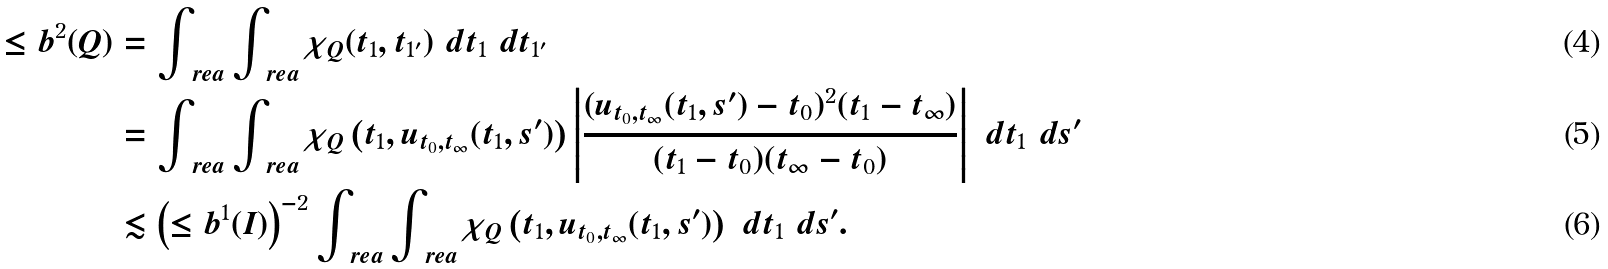Convert formula to latex. <formula><loc_0><loc_0><loc_500><loc_500>\leq b ^ { 2 } ( Q ) & = \int _ { \ r e a } \int _ { \ r e a } \chi _ { Q } ( t _ { 1 } , t _ { 1 ^ { \prime } } ) \ d t _ { 1 } \ d t _ { 1 ^ { \prime } } \\ & = \int _ { \ r e a } \int _ { \ r e a } \chi _ { Q } \left ( t _ { 1 } , u _ { t _ { 0 } , t _ { \infty } } ( t _ { 1 } , s ^ { \prime } ) \right ) \left | \frac { ( u _ { t _ { 0 } , t _ { \infty } } ( t _ { 1 } , s ^ { \prime } ) - t _ { 0 } ) ^ { 2 } ( t _ { 1 } - t _ { \infty } ) } { ( t _ { 1 } - t _ { 0 } ) ( t _ { \infty } - t _ { 0 } ) } \right | \ d t _ { 1 } \ d s ^ { \prime } \\ & \lesssim \left ( \leq b ^ { 1 } ( I ) \right ) ^ { - 2 } \int _ { \ r e a } \int _ { \ r e a } \chi _ { Q } \left ( t _ { 1 } , u _ { t _ { 0 } , t _ { \infty } } ( t _ { 1 } , s ^ { \prime } ) \right ) \ d t _ { 1 } \ d s ^ { \prime } .</formula> 